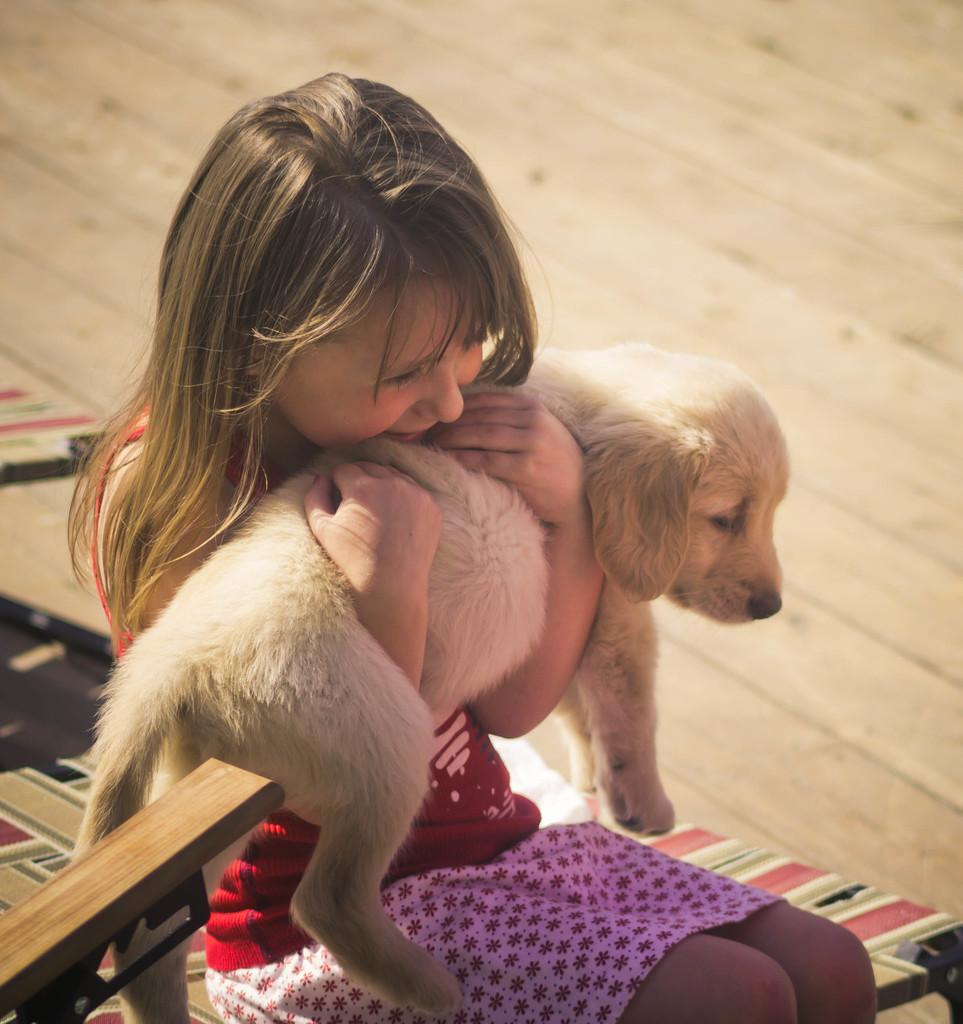Who is the main subject in the image? There is a girl in the image. What is the girl holding in the image? The girl is holding a dog. What type of machine can be seen in the image? There is no machine present in the image; it features a girl holding a dog. How many fish are visible in the image? There are no fish present in the image. 